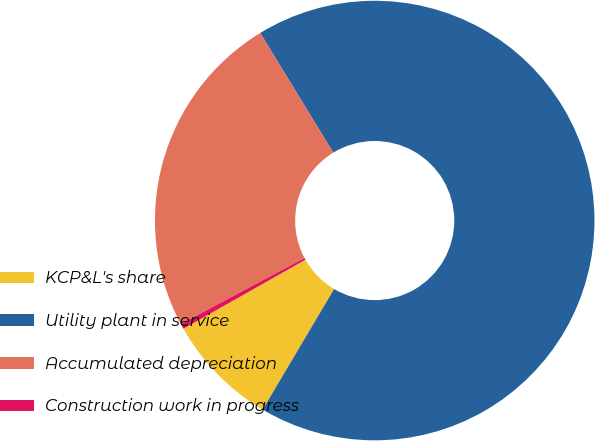Convert chart. <chart><loc_0><loc_0><loc_500><loc_500><pie_chart><fcel>KCP&L's share<fcel>Utility plant in service<fcel>Accumulated depreciation<fcel>Construction work in progress<nl><fcel>8.29%<fcel>67.24%<fcel>24.08%<fcel>0.39%<nl></chart> 